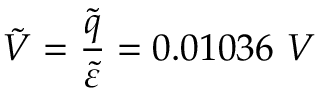<formula> <loc_0><loc_0><loc_500><loc_500>\tilde { V } = \frac { \tilde { q } } { \tilde { \varepsilon } } = 0 . 0 1 0 3 6 V</formula> 